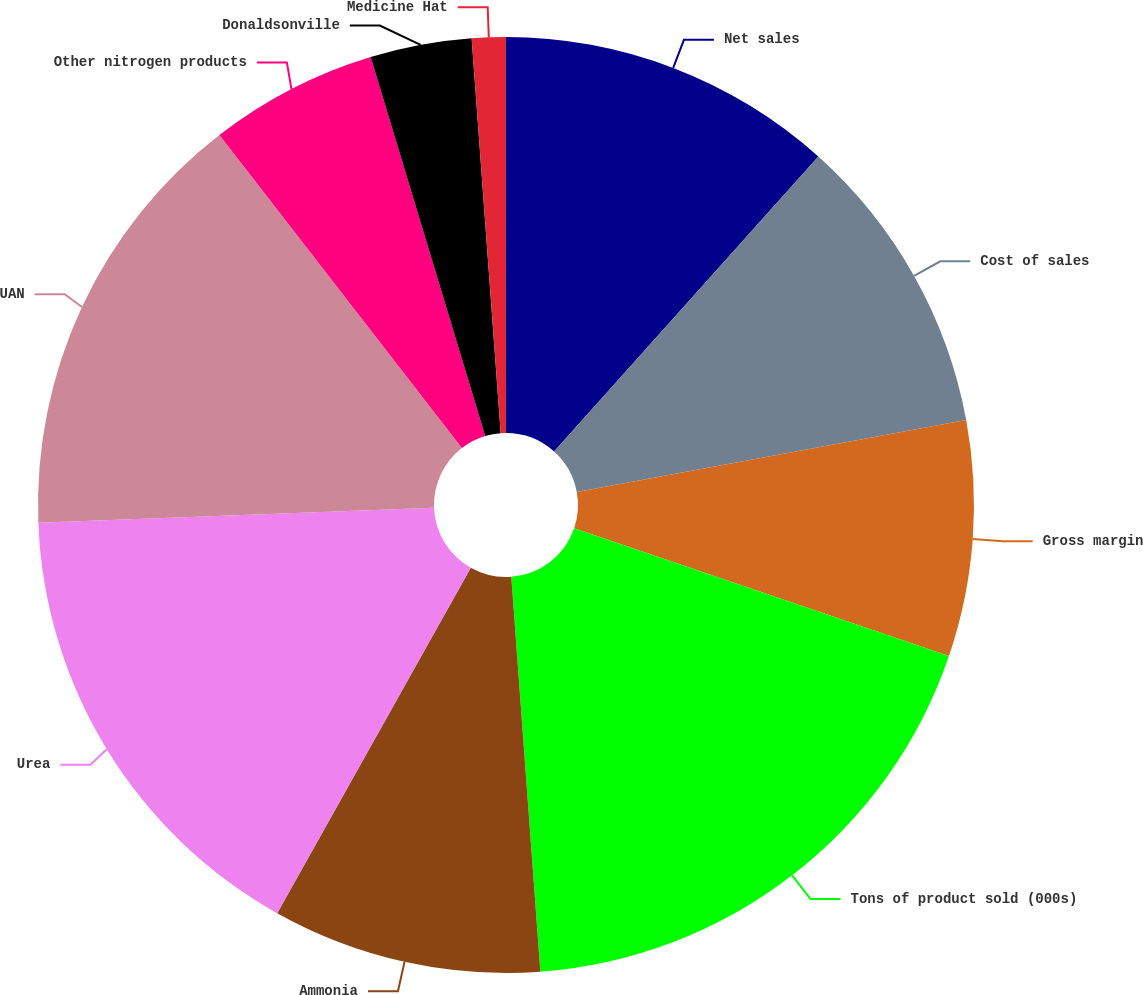<chart> <loc_0><loc_0><loc_500><loc_500><pie_chart><fcel>Net sales<fcel>Cost of sales<fcel>Gross margin<fcel>Tons of product sold (000s)<fcel>Ammonia<fcel>Urea<fcel>UAN<fcel>Other nitrogen products<fcel>Donaldsonville<fcel>Medicine Hat<nl><fcel>11.63%<fcel>10.46%<fcel>8.14%<fcel>18.6%<fcel>9.3%<fcel>16.27%<fcel>15.11%<fcel>5.82%<fcel>3.5%<fcel>1.17%<nl></chart> 